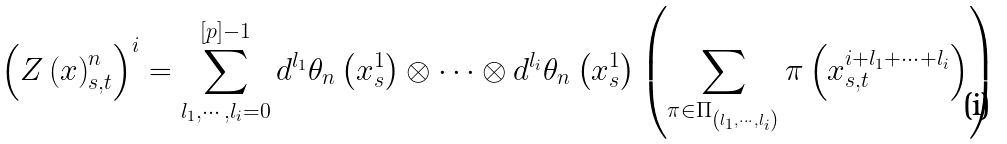<formula> <loc_0><loc_0><loc_500><loc_500>\left ( Z \left ( x \right ) _ { s , t } ^ { n } \right ) ^ { i } = \sum _ { l _ { 1 } , \cdots , l _ { i } = 0 } ^ { [ p ] - 1 } d ^ { l _ { 1 } } \theta _ { n } \left ( x _ { s } ^ { 1 } \right ) \otimes \cdots \otimes d ^ { l _ { i } } \theta _ { n } \left ( x _ { s } ^ { 1 } \right ) \left ( \sum _ { \pi \in \Pi _ { \left ( l _ { 1 } , \cdots , l _ { i } \right ) } } \pi \left ( x _ { s , t } ^ { i + l _ { 1 } + \cdots + l _ { i } } \right ) \right )</formula> 